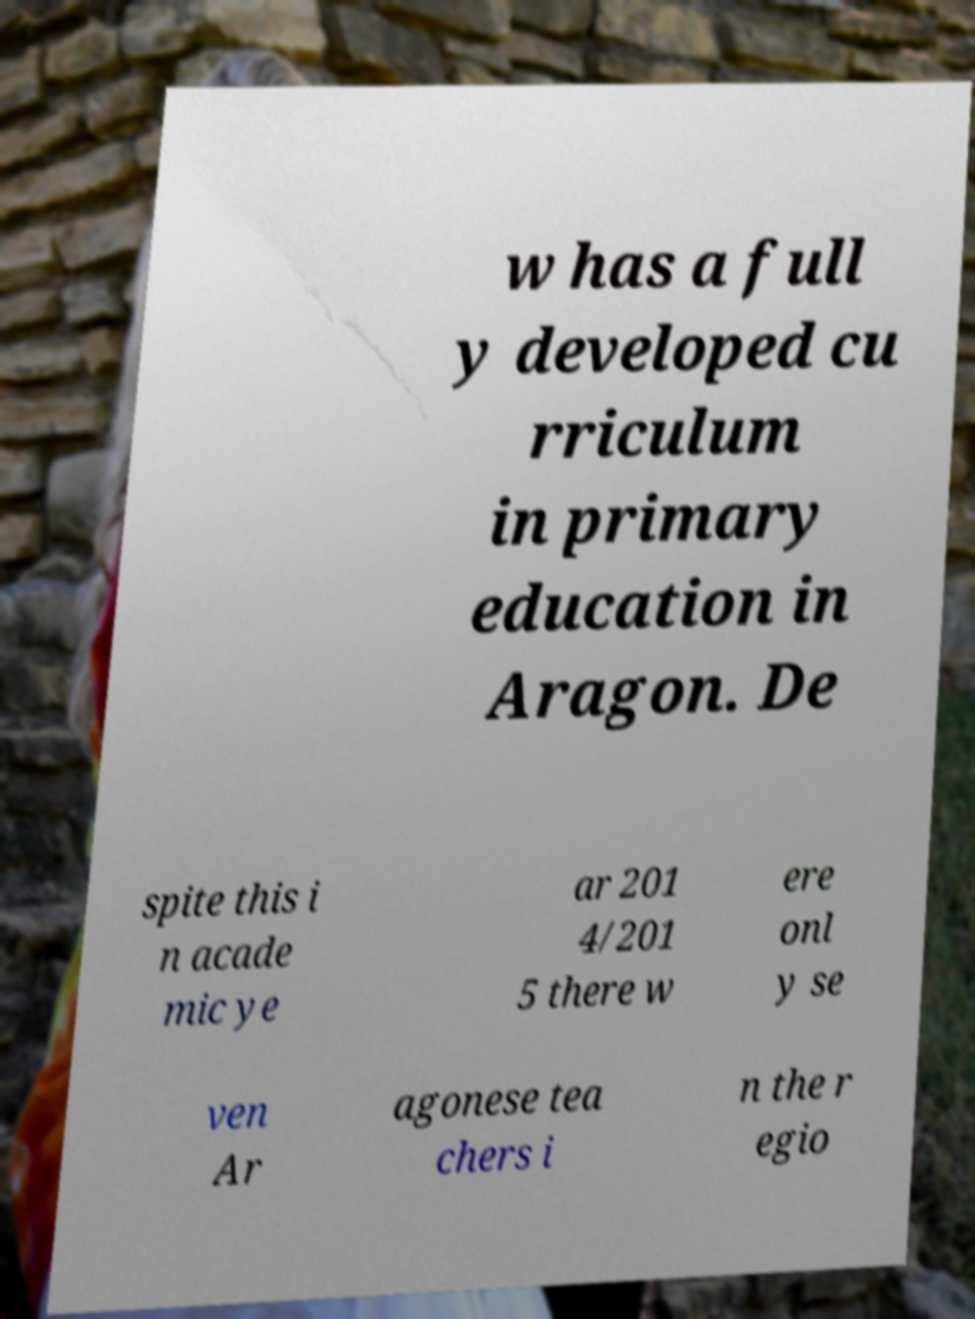Could you extract and type out the text from this image? w has a full y developed cu rriculum in primary education in Aragon. De spite this i n acade mic ye ar 201 4/201 5 there w ere onl y se ven Ar agonese tea chers i n the r egio 